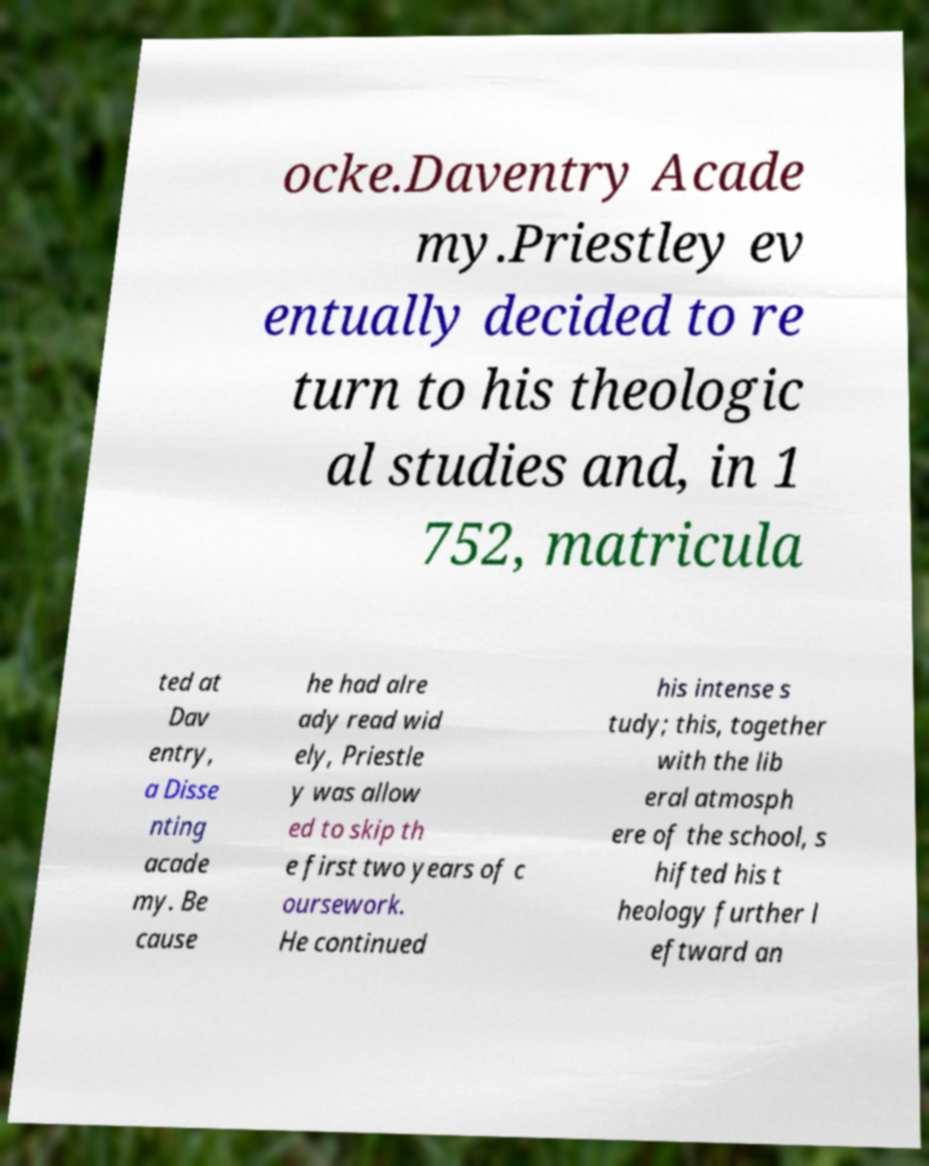There's text embedded in this image that I need extracted. Can you transcribe it verbatim? ocke.Daventry Acade my.Priestley ev entually decided to re turn to his theologic al studies and, in 1 752, matricula ted at Dav entry, a Disse nting acade my. Be cause he had alre ady read wid ely, Priestle y was allow ed to skip th e first two years of c oursework. He continued his intense s tudy; this, together with the lib eral atmosph ere of the school, s hifted his t heology further l eftward an 